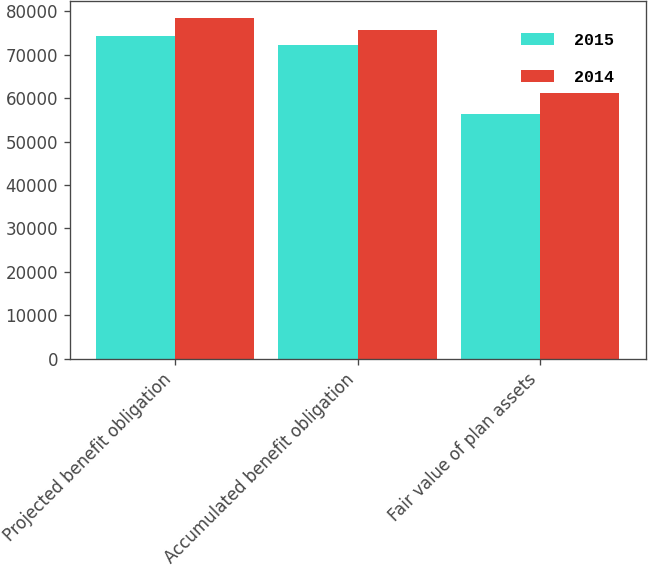Convert chart. <chart><loc_0><loc_0><loc_500><loc_500><stacked_bar_chart><ecel><fcel>Projected benefit obligation<fcel>Accumulated benefit obligation<fcel>Fair value of plan assets<nl><fcel>2015<fcel>74188<fcel>72121<fcel>56306<nl><fcel>2014<fcel>78358<fcel>75622<fcel>61082<nl></chart> 